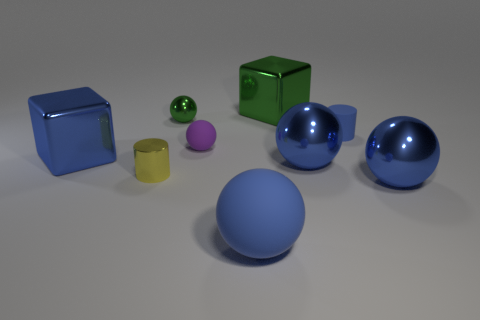Subtract all blue balls. How many were subtracted if there are1blue balls left? 2 Subtract all red cylinders. How many blue spheres are left? 3 Subtract all green spheres. How many spheres are left? 4 Subtract all tiny purple matte spheres. How many spheres are left? 4 Subtract all yellow balls. Subtract all yellow cubes. How many balls are left? 5 Subtract all cubes. How many objects are left? 7 Add 5 large blue rubber things. How many large blue rubber things exist? 6 Subtract 0 yellow spheres. How many objects are left? 9 Subtract all blue things. Subtract all yellow metal spheres. How many objects are left? 4 Add 3 yellow metal objects. How many yellow metal objects are left? 4 